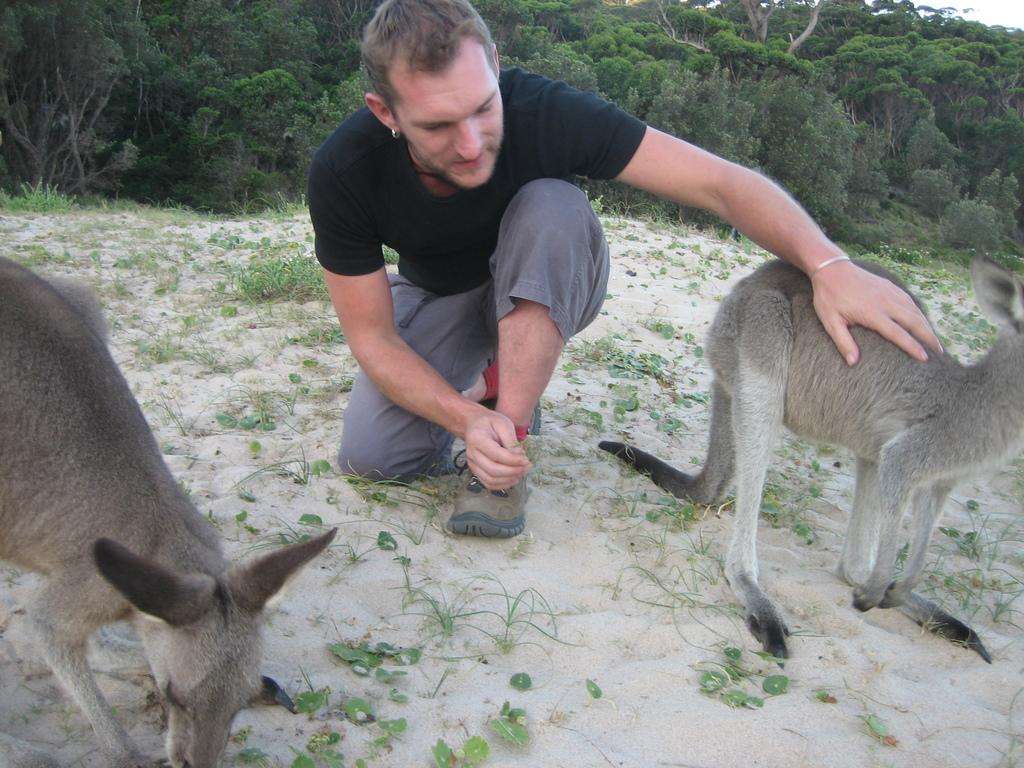Who is present in the image? There is a man in the image. What is the man doing in the image? The man is standing on his knees. What is the man doing near in the image? The man is beside animals. What type of natural environment is depicted in the image? There are trees, shrubs, grass, and sand in the image. What game is the man playing with the animals in the image? There is no game being played in the image; the man is simply standing beside the animals. 